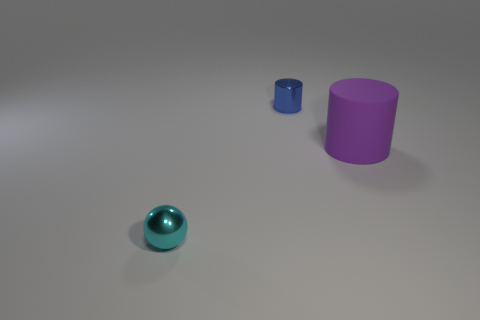Add 2 green metal objects. How many objects exist? 5 Add 3 metallic cylinders. How many metallic cylinders are left? 4 Add 1 purple matte things. How many purple matte things exist? 2 Subtract 1 blue cylinders. How many objects are left? 2 Subtract all cylinders. How many objects are left? 1 Subtract all cyan metal balls. Subtract all small shiny spheres. How many objects are left? 1 